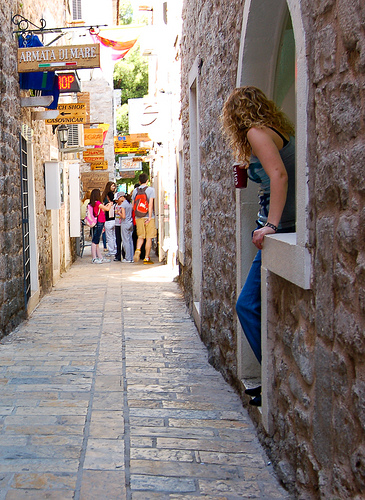<image>
Is there a woman behind the cup? Yes. From this viewpoint, the woman is positioned behind the cup, with the cup partially or fully occluding the woman. 